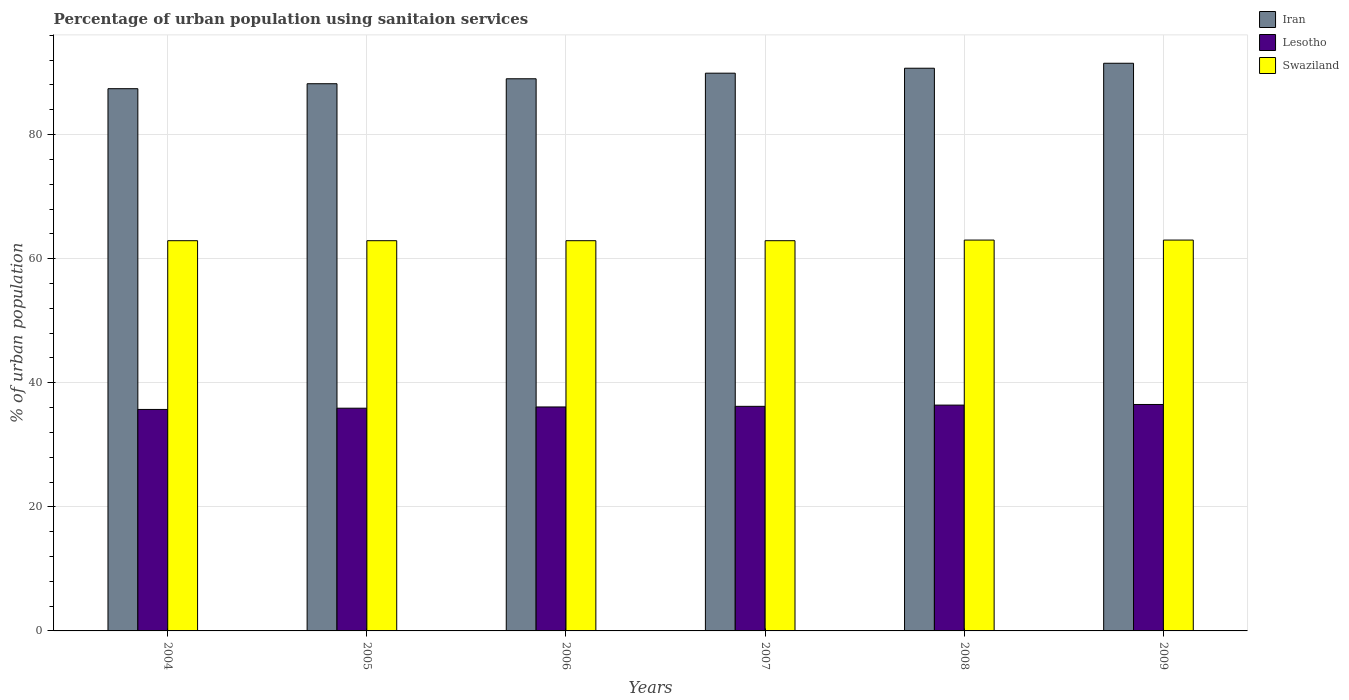How many groups of bars are there?
Offer a very short reply. 6. How many bars are there on the 2nd tick from the right?
Your response must be concise. 3. What is the label of the 3rd group of bars from the left?
Make the answer very short. 2006. What is the percentage of urban population using sanitaion services in Iran in 2006?
Give a very brief answer. 89. Across all years, what is the maximum percentage of urban population using sanitaion services in Iran?
Provide a succinct answer. 91.5. Across all years, what is the minimum percentage of urban population using sanitaion services in Swaziland?
Provide a short and direct response. 62.9. In which year was the percentage of urban population using sanitaion services in Lesotho maximum?
Your response must be concise. 2009. In which year was the percentage of urban population using sanitaion services in Swaziland minimum?
Keep it short and to the point. 2004. What is the total percentage of urban population using sanitaion services in Lesotho in the graph?
Offer a very short reply. 216.8. What is the difference between the percentage of urban population using sanitaion services in Swaziland in 2005 and that in 2008?
Your answer should be very brief. -0.1. What is the difference between the percentage of urban population using sanitaion services in Iran in 2007 and the percentage of urban population using sanitaion services in Swaziland in 2005?
Provide a succinct answer. 27. What is the average percentage of urban population using sanitaion services in Iran per year?
Your answer should be very brief. 89.45. In the year 2008, what is the difference between the percentage of urban population using sanitaion services in Iran and percentage of urban population using sanitaion services in Lesotho?
Offer a terse response. 54.3. In how many years, is the percentage of urban population using sanitaion services in Swaziland greater than 36 %?
Ensure brevity in your answer.  6. What is the ratio of the percentage of urban population using sanitaion services in Iran in 2004 to that in 2005?
Give a very brief answer. 0.99. Is the percentage of urban population using sanitaion services in Swaziland in 2004 less than that in 2009?
Offer a terse response. Yes. Is the difference between the percentage of urban population using sanitaion services in Iran in 2005 and 2009 greater than the difference between the percentage of urban population using sanitaion services in Lesotho in 2005 and 2009?
Ensure brevity in your answer.  No. What is the difference between the highest and the second highest percentage of urban population using sanitaion services in Iran?
Offer a very short reply. 0.8. What is the difference between the highest and the lowest percentage of urban population using sanitaion services in Iran?
Your response must be concise. 4.1. What does the 3rd bar from the left in 2007 represents?
Your answer should be compact. Swaziland. What does the 2nd bar from the right in 2009 represents?
Ensure brevity in your answer.  Lesotho. Is it the case that in every year, the sum of the percentage of urban population using sanitaion services in Lesotho and percentage of urban population using sanitaion services in Swaziland is greater than the percentage of urban population using sanitaion services in Iran?
Provide a succinct answer. Yes. Are the values on the major ticks of Y-axis written in scientific E-notation?
Give a very brief answer. No. Does the graph contain any zero values?
Your answer should be compact. No. Where does the legend appear in the graph?
Keep it short and to the point. Top right. What is the title of the graph?
Your answer should be compact. Percentage of urban population using sanitaion services. Does "Timor-Leste" appear as one of the legend labels in the graph?
Offer a terse response. No. What is the label or title of the Y-axis?
Provide a short and direct response. % of urban population. What is the % of urban population of Iran in 2004?
Provide a short and direct response. 87.4. What is the % of urban population in Lesotho in 2004?
Make the answer very short. 35.7. What is the % of urban population of Swaziland in 2004?
Your answer should be very brief. 62.9. What is the % of urban population of Iran in 2005?
Make the answer very short. 88.2. What is the % of urban population in Lesotho in 2005?
Provide a short and direct response. 35.9. What is the % of urban population in Swaziland in 2005?
Offer a terse response. 62.9. What is the % of urban population of Iran in 2006?
Offer a terse response. 89. What is the % of urban population of Lesotho in 2006?
Offer a very short reply. 36.1. What is the % of urban population of Swaziland in 2006?
Ensure brevity in your answer.  62.9. What is the % of urban population of Iran in 2007?
Your answer should be very brief. 89.9. What is the % of urban population of Lesotho in 2007?
Ensure brevity in your answer.  36.2. What is the % of urban population in Swaziland in 2007?
Keep it short and to the point. 62.9. What is the % of urban population of Iran in 2008?
Keep it short and to the point. 90.7. What is the % of urban population in Lesotho in 2008?
Your answer should be very brief. 36.4. What is the % of urban population in Iran in 2009?
Ensure brevity in your answer.  91.5. What is the % of urban population of Lesotho in 2009?
Ensure brevity in your answer.  36.5. Across all years, what is the maximum % of urban population in Iran?
Give a very brief answer. 91.5. Across all years, what is the maximum % of urban population in Lesotho?
Your response must be concise. 36.5. Across all years, what is the minimum % of urban population in Iran?
Ensure brevity in your answer.  87.4. Across all years, what is the minimum % of urban population in Lesotho?
Provide a succinct answer. 35.7. Across all years, what is the minimum % of urban population of Swaziland?
Offer a terse response. 62.9. What is the total % of urban population of Iran in the graph?
Provide a short and direct response. 536.7. What is the total % of urban population in Lesotho in the graph?
Keep it short and to the point. 216.8. What is the total % of urban population in Swaziland in the graph?
Provide a succinct answer. 377.6. What is the difference between the % of urban population of Iran in 2004 and that in 2005?
Your answer should be very brief. -0.8. What is the difference between the % of urban population of Swaziland in 2004 and that in 2005?
Offer a terse response. 0. What is the difference between the % of urban population of Iran in 2004 and that in 2006?
Your response must be concise. -1.6. What is the difference between the % of urban population of Lesotho in 2004 and that in 2006?
Your answer should be very brief. -0.4. What is the difference between the % of urban population in Iran in 2004 and that in 2007?
Offer a terse response. -2.5. What is the difference between the % of urban population of Swaziland in 2004 and that in 2007?
Your response must be concise. 0. What is the difference between the % of urban population in Lesotho in 2004 and that in 2008?
Your response must be concise. -0.7. What is the difference between the % of urban population in Swaziland in 2004 and that in 2008?
Your answer should be compact. -0.1. What is the difference between the % of urban population in Lesotho in 2004 and that in 2009?
Provide a succinct answer. -0.8. What is the difference between the % of urban population of Swaziland in 2004 and that in 2009?
Your answer should be compact. -0.1. What is the difference between the % of urban population in Iran in 2005 and that in 2006?
Offer a very short reply. -0.8. What is the difference between the % of urban population of Iran in 2005 and that in 2007?
Give a very brief answer. -1.7. What is the difference between the % of urban population of Lesotho in 2005 and that in 2007?
Provide a succinct answer. -0.3. What is the difference between the % of urban population of Swaziland in 2005 and that in 2007?
Your answer should be compact. 0. What is the difference between the % of urban population in Lesotho in 2005 and that in 2008?
Offer a very short reply. -0.5. What is the difference between the % of urban population in Swaziland in 2005 and that in 2008?
Ensure brevity in your answer.  -0.1. What is the difference between the % of urban population in Iran in 2005 and that in 2009?
Make the answer very short. -3.3. What is the difference between the % of urban population of Lesotho in 2005 and that in 2009?
Provide a succinct answer. -0.6. What is the difference between the % of urban population in Swaziland in 2005 and that in 2009?
Offer a very short reply. -0.1. What is the difference between the % of urban population of Lesotho in 2006 and that in 2007?
Make the answer very short. -0.1. What is the difference between the % of urban population in Swaziland in 2006 and that in 2007?
Offer a terse response. 0. What is the difference between the % of urban population of Lesotho in 2006 and that in 2008?
Keep it short and to the point. -0.3. What is the difference between the % of urban population of Swaziland in 2006 and that in 2009?
Offer a terse response. -0.1. What is the difference between the % of urban population of Swaziland in 2008 and that in 2009?
Your answer should be compact. 0. What is the difference between the % of urban population of Iran in 2004 and the % of urban population of Lesotho in 2005?
Offer a terse response. 51.5. What is the difference between the % of urban population in Iran in 2004 and the % of urban population in Swaziland in 2005?
Your answer should be compact. 24.5. What is the difference between the % of urban population of Lesotho in 2004 and the % of urban population of Swaziland in 2005?
Provide a succinct answer. -27.2. What is the difference between the % of urban population of Iran in 2004 and the % of urban population of Lesotho in 2006?
Keep it short and to the point. 51.3. What is the difference between the % of urban population in Iran in 2004 and the % of urban population in Swaziland in 2006?
Provide a short and direct response. 24.5. What is the difference between the % of urban population in Lesotho in 2004 and the % of urban population in Swaziland in 2006?
Offer a terse response. -27.2. What is the difference between the % of urban population of Iran in 2004 and the % of urban population of Lesotho in 2007?
Provide a succinct answer. 51.2. What is the difference between the % of urban population in Iran in 2004 and the % of urban population in Swaziland in 2007?
Provide a short and direct response. 24.5. What is the difference between the % of urban population of Lesotho in 2004 and the % of urban population of Swaziland in 2007?
Your answer should be very brief. -27.2. What is the difference between the % of urban population of Iran in 2004 and the % of urban population of Lesotho in 2008?
Your response must be concise. 51. What is the difference between the % of urban population of Iran in 2004 and the % of urban population of Swaziland in 2008?
Offer a terse response. 24.4. What is the difference between the % of urban population in Lesotho in 2004 and the % of urban population in Swaziland in 2008?
Your response must be concise. -27.3. What is the difference between the % of urban population of Iran in 2004 and the % of urban population of Lesotho in 2009?
Provide a short and direct response. 50.9. What is the difference between the % of urban population in Iran in 2004 and the % of urban population in Swaziland in 2009?
Provide a succinct answer. 24.4. What is the difference between the % of urban population of Lesotho in 2004 and the % of urban population of Swaziland in 2009?
Provide a short and direct response. -27.3. What is the difference between the % of urban population of Iran in 2005 and the % of urban population of Lesotho in 2006?
Your answer should be very brief. 52.1. What is the difference between the % of urban population of Iran in 2005 and the % of urban population of Swaziland in 2006?
Your answer should be very brief. 25.3. What is the difference between the % of urban population in Lesotho in 2005 and the % of urban population in Swaziland in 2006?
Your answer should be very brief. -27. What is the difference between the % of urban population of Iran in 2005 and the % of urban population of Swaziland in 2007?
Offer a terse response. 25.3. What is the difference between the % of urban population in Iran in 2005 and the % of urban population in Lesotho in 2008?
Your answer should be compact. 51.8. What is the difference between the % of urban population of Iran in 2005 and the % of urban population of Swaziland in 2008?
Keep it short and to the point. 25.2. What is the difference between the % of urban population in Lesotho in 2005 and the % of urban population in Swaziland in 2008?
Keep it short and to the point. -27.1. What is the difference between the % of urban population of Iran in 2005 and the % of urban population of Lesotho in 2009?
Ensure brevity in your answer.  51.7. What is the difference between the % of urban population in Iran in 2005 and the % of urban population in Swaziland in 2009?
Provide a short and direct response. 25.2. What is the difference between the % of urban population in Lesotho in 2005 and the % of urban population in Swaziland in 2009?
Offer a very short reply. -27.1. What is the difference between the % of urban population of Iran in 2006 and the % of urban population of Lesotho in 2007?
Your answer should be very brief. 52.8. What is the difference between the % of urban population in Iran in 2006 and the % of urban population in Swaziland in 2007?
Your answer should be very brief. 26.1. What is the difference between the % of urban population in Lesotho in 2006 and the % of urban population in Swaziland in 2007?
Provide a succinct answer. -26.8. What is the difference between the % of urban population of Iran in 2006 and the % of urban population of Lesotho in 2008?
Offer a terse response. 52.6. What is the difference between the % of urban population of Iran in 2006 and the % of urban population of Swaziland in 2008?
Offer a terse response. 26. What is the difference between the % of urban population in Lesotho in 2006 and the % of urban population in Swaziland in 2008?
Your response must be concise. -26.9. What is the difference between the % of urban population in Iran in 2006 and the % of urban population in Lesotho in 2009?
Your answer should be compact. 52.5. What is the difference between the % of urban population of Lesotho in 2006 and the % of urban population of Swaziland in 2009?
Your answer should be very brief. -26.9. What is the difference between the % of urban population of Iran in 2007 and the % of urban population of Lesotho in 2008?
Your answer should be compact. 53.5. What is the difference between the % of urban population in Iran in 2007 and the % of urban population in Swaziland in 2008?
Offer a very short reply. 26.9. What is the difference between the % of urban population in Lesotho in 2007 and the % of urban population in Swaziland in 2008?
Make the answer very short. -26.8. What is the difference between the % of urban population of Iran in 2007 and the % of urban population of Lesotho in 2009?
Provide a succinct answer. 53.4. What is the difference between the % of urban population of Iran in 2007 and the % of urban population of Swaziland in 2009?
Keep it short and to the point. 26.9. What is the difference between the % of urban population in Lesotho in 2007 and the % of urban population in Swaziland in 2009?
Provide a short and direct response. -26.8. What is the difference between the % of urban population of Iran in 2008 and the % of urban population of Lesotho in 2009?
Give a very brief answer. 54.2. What is the difference between the % of urban population of Iran in 2008 and the % of urban population of Swaziland in 2009?
Give a very brief answer. 27.7. What is the difference between the % of urban population of Lesotho in 2008 and the % of urban population of Swaziland in 2009?
Your answer should be very brief. -26.6. What is the average % of urban population of Iran per year?
Offer a very short reply. 89.45. What is the average % of urban population in Lesotho per year?
Provide a short and direct response. 36.13. What is the average % of urban population in Swaziland per year?
Keep it short and to the point. 62.93. In the year 2004, what is the difference between the % of urban population of Iran and % of urban population of Lesotho?
Your response must be concise. 51.7. In the year 2004, what is the difference between the % of urban population of Lesotho and % of urban population of Swaziland?
Make the answer very short. -27.2. In the year 2005, what is the difference between the % of urban population of Iran and % of urban population of Lesotho?
Provide a succinct answer. 52.3. In the year 2005, what is the difference between the % of urban population in Iran and % of urban population in Swaziland?
Offer a very short reply. 25.3. In the year 2005, what is the difference between the % of urban population in Lesotho and % of urban population in Swaziland?
Offer a very short reply. -27. In the year 2006, what is the difference between the % of urban population of Iran and % of urban population of Lesotho?
Provide a succinct answer. 52.9. In the year 2006, what is the difference between the % of urban population in Iran and % of urban population in Swaziland?
Your answer should be very brief. 26.1. In the year 2006, what is the difference between the % of urban population in Lesotho and % of urban population in Swaziland?
Keep it short and to the point. -26.8. In the year 2007, what is the difference between the % of urban population of Iran and % of urban population of Lesotho?
Provide a succinct answer. 53.7. In the year 2007, what is the difference between the % of urban population in Iran and % of urban population in Swaziland?
Make the answer very short. 27. In the year 2007, what is the difference between the % of urban population of Lesotho and % of urban population of Swaziland?
Your response must be concise. -26.7. In the year 2008, what is the difference between the % of urban population in Iran and % of urban population in Lesotho?
Provide a short and direct response. 54.3. In the year 2008, what is the difference between the % of urban population of Iran and % of urban population of Swaziland?
Provide a short and direct response. 27.7. In the year 2008, what is the difference between the % of urban population in Lesotho and % of urban population in Swaziland?
Your response must be concise. -26.6. In the year 2009, what is the difference between the % of urban population in Lesotho and % of urban population in Swaziland?
Offer a very short reply. -26.5. What is the ratio of the % of urban population in Iran in 2004 to that in 2005?
Provide a short and direct response. 0.99. What is the ratio of the % of urban population of Lesotho in 2004 to that in 2005?
Offer a very short reply. 0.99. What is the ratio of the % of urban population in Swaziland in 2004 to that in 2005?
Make the answer very short. 1. What is the ratio of the % of urban population in Lesotho in 2004 to that in 2006?
Provide a succinct answer. 0.99. What is the ratio of the % of urban population in Iran in 2004 to that in 2007?
Your answer should be compact. 0.97. What is the ratio of the % of urban population in Lesotho in 2004 to that in 2007?
Offer a very short reply. 0.99. What is the ratio of the % of urban population of Swaziland in 2004 to that in 2007?
Provide a short and direct response. 1. What is the ratio of the % of urban population of Iran in 2004 to that in 2008?
Make the answer very short. 0.96. What is the ratio of the % of urban population in Lesotho in 2004 to that in 2008?
Provide a short and direct response. 0.98. What is the ratio of the % of urban population in Swaziland in 2004 to that in 2008?
Offer a terse response. 1. What is the ratio of the % of urban population of Iran in 2004 to that in 2009?
Give a very brief answer. 0.96. What is the ratio of the % of urban population in Lesotho in 2004 to that in 2009?
Your answer should be very brief. 0.98. What is the ratio of the % of urban population of Swaziland in 2005 to that in 2006?
Your answer should be very brief. 1. What is the ratio of the % of urban population in Iran in 2005 to that in 2007?
Your answer should be compact. 0.98. What is the ratio of the % of urban population in Lesotho in 2005 to that in 2007?
Give a very brief answer. 0.99. What is the ratio of the % of urban population of Swaziland in 2005 to that in 2007?
Offer a very short reply. 1. What is the ratio of the % of urban population in Iran in 2005 to that in 2008?
Provide a succinct answer. 0.97. What is the ratio of the % of urban population of Lesotho in 2005 to that in 2008?
Your answer should be very brief. 0.99. What is the ratio of the % of urban population of Iran in 2005 to that in 2009?
Your answer should be compact. 0.96. What is the ratio of the % of urban population of Lesotho in 2005 to that in 2009?
Make the answer very short. 0.98. What is the ratio of the % of urban population of Iran in 2006 to that in 2007?
Provide a succinct answer. 0.99. What is the ratio of the % of urban population in Iran in 2006 to that in 2008?
Make the answer very short. 0.98. What is the ratio of the % of urban population in Lesotho in 2006 to that in 2008?
Provide a succinct answer. 0.99. What is the ratio of the % of urban population of Iran in 2006 to that in 2009?
Your answer should be compact. 0.97. What is the ratio of the % of urban population in Lesotho in 2006 to that in 2009?
Offer a very short reply. 0.99. What is the ratio of the % of urban population in Swaziland in 2007 to that in 2008?
Keep it short and to the point. 1. What is the ratio of the % of urban population of Iran in 2007 to that in 2009?
Your response must be concise. 0.98. What is the ratio of the % of urban population of Lesotho in 2007 to that in 2009?
Make the answer very short. 0.99. What is the ratio of the % of urban population in Swaziland in 2007 to that in 2009?
Your answer should be compact. 1. What is the ratio of the % of urban population of Iran in 2008 to that in 2009?
Offer a terse response. 0.99. What is the ratio of the % of urban population of Lesotho in 2008 to that in 2009?
Keep it short and to the point. 1. What is the ratio of the % of urban population in Swaziland in 2008 to that in 2009?
Your response must be concise. 1. What is the difference between the highest and the second highest % of urban population of Lesotho?
Your response must be concise. 0.1. What is the difference between the highest and the lowest % of urban population in Iran?
Make the answer very short. 4.1. What is the difference between the highest and the lowest % of urban population in Swaziland?
Your answer should be compact. 0.1. 